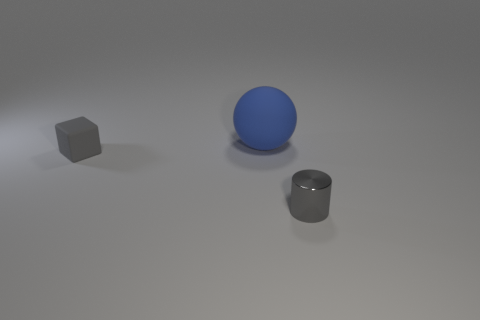Subtract all purple balls. Subtract all purple blocks. How many balls are left? 1 Add 2 big shiny blocks. How many objects exist? 5 Subtract all cylinders. How many objects are left? 2 Add 3 large blue matte objects. How many large blue matte objects exist? 4 Subtract 0 cyan spheres. How many objects are left? 3 Subtract all purple matte objects. Subtract all gray cylinders. How many objects are left? 2 Add 1 balls. How many balls are left? 2 